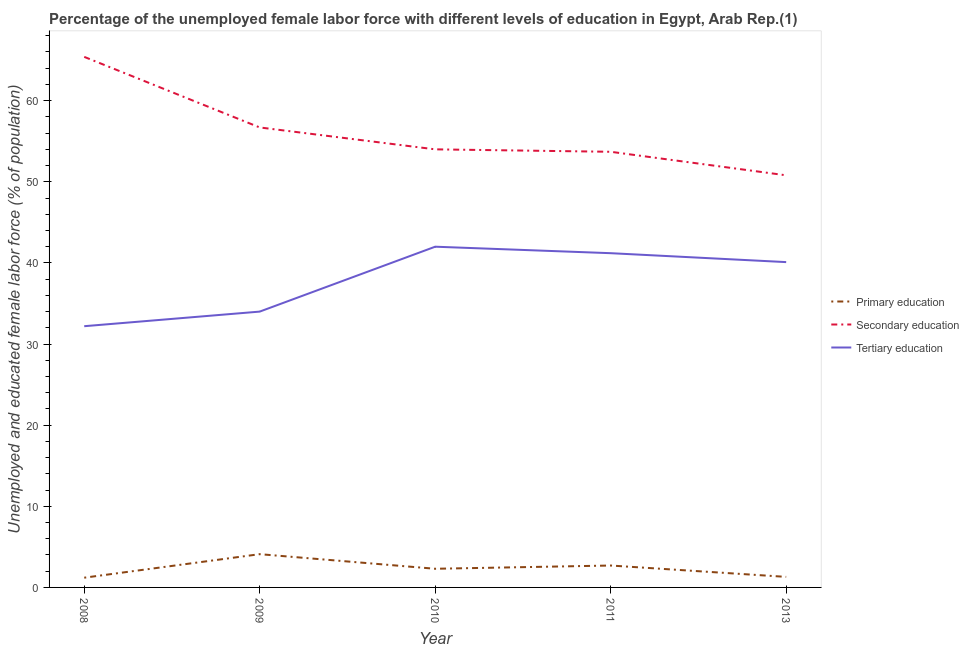How many different coloured lines are there?
Ensure brevity in your answer.  3. Does the line corresponding to percentage of female labor force who received primary education intersect with the line corresponding to percentage of female labor force who received secondary education?
Make the answer very short. No. What is the percentage of female labor force who received primary education in 2008?
Your answer should be compact. 1.2. Across all years, what is the minimum percentage of female labor force who received secondary education?
Ensure brevity in your answer.  50.8. In which year was the percentage of female labor force who received secondary education maximum?
Ensure brevity in your answer.  2008. In which year was the percentage of female labor force who received tertiary education minimum?
Provide a short and direct response. 2008. What is the total percentage of female labor force who received primary education in the graph?
Offer a very short reply. 11.6. What is the difference between the percentage of female labor force who received primary education in 2009 and that in 2013?
Keep it short and to the point. 2.8. What is the difference between the percentage of female labor force who received secondary education in 2010 and the percentage of female labor force who received tertiary education in 2011?
Provide a short and direct response. 12.8. What is the average percentage of female labor force who received secondary education per year?
Make the answer very short. 56.12. In the year 2009, what is the difference between the percentage of female labor force who received primary education and percentage of female labor force who received secondary education?
Keep it short and to the point. -52.6. What is the ratio of the percentage of female labor force who received tertiary education in 2008 to that in 2009?
Your response must be concise. 0.95. Is the difference between the percentage of female labor force who received primary education in 2008 and 2013 greater than the difference between the percentage of female labor force who received secondary education in 2008 and 2013?
Provide a succinct answer. No. What is the difference between the highest and the second highest percentage of female labor force who received primary education?
Ensure brevity in your answer.  1.4. What is the difference between the highest and the lowest percentage of female labor force who received secondary education?
Offer a terse response. 14.6. Is it the case that in every year, the sum of the percentage of female labor force who received primary education and percentage of female labor force who received secondary education is greater than the percentage of female labor force who received tertiary education?
Provide a succinct answer. Yes. Does the percentage of female labor force who received secondary education monotonically increase over the years?
Offer a very short reply. No. Is the percentage of female labor force who received tertiary education strictly less than the percentage of female labor force who received primary education over the years?
Give a very brief answer. No. How many years are there in the graph?
Provide a short and direct response. 5. What is the difference between two consecutive major ticks on the Y-axis?
Your answer should be very brief. 10. Are the values on the major ticks of Y-axis written in scientific E-notation?
Make the answer very short. No. What is the title of the graph?
Keep it short and to the point. Percentage of the unemployed female labor force with different levels of education in Egypt, Arab Rep.(1). Does "Unemployment benefits" appear as one of the legend labels in the graph?
Give a very brief answer. No. What is the label or title of the X-axis?
Keep it short and to the point. Year. What is the label or title of the Y-axis?
Your response must be concise. Unemployed and educated female labor force (% of population). What is the Unemployed and educated female labor force (% of population) in Primary education in 2008?
Your response must be concise. 1.2. What is the Unemployed and educated female labor force (% of population) in Secondary education in 2008?
Your answer should be compact. 65.4. What is the Unemployed and educated female labor force (% of population) in Tertiary education in 2008?
Make the answer very short. 32.2. What is the Unemployed and educated female labor force (% of population) in Primary education in 2009?
Keep it short and to the point. 4.1. What is the Unemployed and educated female labor force (% of population) of Secondary education in 2009?
Give a very brief answer. 56.7. What is the Unemployed and educated female labor force (% of population) in Primary education in 2010?
Your answer should be very brief. 2.3. What is the Unemployed and educated female labor force (% of population) of Secondary education in 2010?
Your answer should be compact. 54. What is the Unemployed and educated female labor force (% of population) in Tertiary education in 2010?
Your answer should be very brief. 42. What is the Unemployed and educated female labor force (% of population) of Primary education in 2011?
Make the answer very short. 2.7. What is the Unemployed and educated female labor force (% of population) in Secondary education in 2011?
Offer a very short reply. 53.7. What is the Unemployed and educated female labor force (% of population) in Tertiary education in 2011?
Offer a terse response. 41.2. What is the Unemployed and educated female labor force (% of population) of Primary education in 2013?
Provide a short and direct response. 1.3. What is the Unemployed and educated female labor force (% of population) in Secondary education in 2013?
Your response must be concise. 50.8. What is the Unemployed and educated female labor force (% of population) of Tertiary education in 2013?
Keep it short and to the point. 40.1. Across all years, what is the maximum Unemployed and educated female labor force (% of population) of Primary education?
Provide a short and direct response. 4.1. Across all years, what is the maximum Unemployed and educated female labor force (% of population) in Secondary education?
Your response must be concise. 65.4. Across all years, what is the maximum Unemployed and educated female labor force (% of population) in Tertiary education?
Ensure brevity in your answer.  42. Across all years, what is the minimum Unemployed and educated female labor force (% of population) of Primary education?
Your answer should be very brief. 1.2. Across all years, what is the minimum Unemployed and educated female labor force (% of population) in Secondary education?
Provide a short and direct response. 50.8. Across all years, what is the minimum Unemployed and educated female labor force (% of population) in Tertiary education?
Ensure brevity in your answer.  32.2. What is the total Unemployed and educated female labor force (% of population) of Secondary education in the graph?
Your response must be concise. 280.6. What is the total Unemployed and educated female labor force (% of population) of Tertiary education in the graph?
Keep it short and to the point. 189.5. What is the difference between the Unemployed and educated female labor force (% of population) of Tertiary education in 2008 and that in 2009?
Offer a very short reply. -1.8. What is the difference between the Unemployed and educated female labor force (% of population) of Tertiary education in 2008 and that in 2010?
Make the answer very short. -9.8. What is the difference between the Unemployed and educated female labor force (% of population) of Secondary education in 2008 and that in 2011?
Provide a succinct answer. 11.7. What is the difference between the Unemployed and educated female labor force (% of population) in Primary education in 2008 and that in 2013?
Give a very brief answer. -0.1. What is the difference between the Unemployed and educated female labor force (% of population) in Secondary education in 2008 and that in 2013?
Offer a very short reply. 14.6. What is the difference between the Unemployed and educated female labor force (% of population) in Tertiary education in 2008 and that in 2013?
Offer a very short reply. -7.9. What is the difference between the Unemployed and educated female labor force (% of population) of Primary education in 2009 and that in 2013?
Make the answer very short. 2.8. What is the difference between the Unemployed and educated female labor force (% of population) in Tertiary education in 2009 and that in 2013?
Offer a very short reply. -6.1. What is the difference between the Unemployed and educated female labor force (% of population) in Primary education in 2010 and that in 2011?
Keep it short and to the point. -0.4. What is the difference between the Unemployed and educated female labor force (% of population) in Secondary education in 2010 and that in 2011?
Provide a succinct answer. 0.3. What is the difference between the Unemployed and educated female labor force (% of population) of Primary education in 2010 and that in 2013?
Keep it short and to the point. 1. What is the difference between the Unemployed and educated female labor force (% of population) in Secondary education in 2010 and that in 2013?
Provide a succinct answer. 3.2. What is the difference between the Unemployed and educated female labor force (% of population) of Tertiary education in 2010 and that in 2013?
Your answer should be compact. 1.9. What is the difference between the Unemployed and educated female labor force (% of population) in Secondary education in 2011 and that in 2013?
Make the answer very short. 2.9. What is the difference between the Unemployed and educated female labor force (% of population) of Primary education in 2008 and the Unemployed and educated female labor force (% of population) of Secondary education in 2009?
Make the answer very short. -55.5. What is the difference between the Unemployed and educated female labor force (% of population) in Primary education in 2008 and the Unemployed and educated female labor force (% of population) in Tertiary education in 2009?
Give a very brief answer. -32.8. What is the difference between the Unemployed and educated female labor force (% of population) in Secondary education in 2008 and the Unemployed and educated female labor force (% of population) in Tertiary education in 2009?
Provide a succinct answer. 31.4. What is the difference between the Unemployed and educated female labor force (% of population) of Primary education in 2008 and the Unemployed and educated female labor force (% of population) of Secondary education in 2010?
Provide a short and direct response. -52.8. What is the difference between the Unemployed and educated female labor force (% of population) in Primary education in 2008 and the Unemployed and educated female labor force (% of population) in Tertiary education in 2010?
Your response must be concise. -40.8. What is the difference between the Unemployed and educated female labor force (% of population) in Secondary education in 2008 and the Unemployed and educated female labor force (% of population) in Tertiary education in 2010?
Ensure brevity in your answer.  23.4. What is the difference between the Unemployed and educated female labor force (% of population) of Primary education in 2008 and the Unemployed and educated female labor force (% of population) of Secondary education in 2011?
Provide a short and direct response. -52.5. What is the difference between the Unemployed and educated female labor force (% of population) in Primary education in 2008 and the Unemployed and educated female labor force (% of population) in Tertiary education in 2011?
Your answer should be very brief. -40. What is the difference between the Unemployed and educated female labor force (% of population) in Secondary education in 2008 and the Unemployed and educated female labor force (% of population) in Tertiary education in 2011?
Your answer should be compact. 24.2. What is the difference between the Unemployed and educated female labor force (% of population) of Primary education in 2008 and the Unemployed and educated female labor force (% of population) of Secondary education in 2013?
Ensure brevity in your answer.  -49.6. What is the difference between the Unemployed and educated female labor force (% of population) of Primary education in 2008 and the Unemployed and educated female labor force (% of population) of Tertiary education in 2013?
Make the answer very short. -38.9. What is the difference between the Unemployed and educated female labor force (% of population) of Secondary education in 2008 and the Unemployed and educated female labor force (% of population) of Tertiary education in 2013?
Your response must be concise. 25.3. What is the difference between the Unemployed and educated female labor force (% of population) of Primary education in 2009 and the Unemployed and educated female labor force (% of population) of Secondary education in 2010?
Your answer should be compact. -49.9. What is the difference between the Unemployed and educated female labor force (% of population) in Primary education in 2009 and the Unemployed and educated female labor force (% of population) in Tertiary education in 2010?
Provide a short and direct response. -37.9. What is the difference between the Unemployed and educated female labor force (% of population) of Secondary education in 2009 and the Unemployed and educated female labor force (% of population) of Tertiary education in 2010?
Provide a short and direct response. 14.7. What is the difference between the Unemployed and educated female labor force (% of population) of Primary education in 2009 and the Unemployed and educated female labor force (% of population) of Secondary education in 2011?
Keep it short and to the point. -49.6. What is the difference between the Unemployed and educated female labor force (% of population) of Primary education in 2009 and the Unemployed and educated female labor force (% of population) of Tertiary education in 2011?
Offer a terse response. -37.1. What is the difference between the Unemployed and educated female labor force (% of population) of Primary education in 2009 and the Unemployed and educated female labor force (% of population) of Secondary education in 2013?
Your answer should be compact. -46.7. What is the difference between the Unemployed and educated female labor force (% of population) of Primary education in 2009 and the Unemployed and educated female labor force (% of population) of Tertiary education in 2013?
Ensure brevity in your answer.  -36. What is the difference between the Unemployed and educated female labor force (% of population) in Secondary education in 2009 and the Unemployed and educated female labor force (% of population) in Tertiary education in 2013?
Offer a very short reply. 16.6. What is the difference between the Unemployed and educated female labor force (% of population) of Primary education in 2010 and the Unemployed and educated female labor force (% of population) of Secondary education in 2011?
Provide a succinct answer. -51.4. What is the difference between the Unemployed and educated female labor force (% of population) of Primary education in 2010 and the Unemployed and educated female labor force (% of population) of Tertiary education in 2011?
Give a very brief answer. -38.9. What is the difference between the Unemployed and educated female labor force (% of population) in Secondary education in 2010 and the Unemployed and educated female labor force (% of population) in Tertiary education in 2011?
Offer a very short reply. 12.8. What is the difference between the Unemployed and educated female labor force (% of population) of Primary education in 2010 and the Unemployed and educated female labor force (% of population) of Secondary education in 2013?
Provide a succinct answer. -48.5. What is the difference between the Unemployed and educated female labor force (% of population) of Primary education in 2010 and the Unemployed and educated female labor force (% of population) of Tertiary education in 2013?
Ensure brevity in your answer.  -37.8. What is the difference between the Unemployed and educated female labor force (% of population) in Primary education in 2011 and the Unemployed and educated female labor force (% of population) in Secondary education in 2013?
Your response must be concise. -48.1. What is the difference between the Unemployed and educated female labor force (% of population) in Primary education in 2011 and the Unemployed and educated female labor force (% of population) in Tertiary education in 2013?
Offer a terse response. -37.4. What is the average Unemployed and educated female labor force (% of population) of Primary education per year?
Give a very brief answer. 2.32. What is the average Unemployed and educated female labor force (% of population) of Secondary education per year?
Provide a succinct answer. 56.12. What is the average Unemployed and educated female labor force (% of population) of Tertiary education per year?
Make the answer very short. 37.9. In the year 2008, what is the difference between the Unemployed and educated female labor force (% of population) in Primary education and Unemployed and educated female labor force (% of population) in Secondary education?
Offer a very short reply. -64.2. In the year 2008, what is the difference between the Unemployed and educated female labor force (% of population) in Primary education and Unemployed and educated female labor force (% of population) in Tertiary education?
Offer a terse response. -31. In the year 2008, what is the difference between the Unemployed and educated female labor force (% of population) of Secondary education and Unemployed and educated female labor force (% of population) of Tertiary education?
Ensure brevity in your answer.  33.2. In the year 2009, what is the difference between the Unemployed and educated female labor force (% of population) in Primary education and Unemployed and educated female labor force (% of population) in Secondary education?
Provide a succinct answer. -52.6. In the year 2009, what is the difference between the Unemployed and educated female labor force (% of population) in Primary education and Unemployed and educated female labor force (% of population) in Tertiary education?
Your answer should be compact. -29.9. In the year 2009, what is the difference between the Unemployed and educated female labor force (% of population) in Secondary education and Unemployed and educated female labor force (% of population) in Tertiary education?
Your response must be concise. 22.7. In the year 2010, what is the difference between the Unemployed and educated female labor force (% of population) of Primary education and Unemployed and educated female labor force (% of population) of Secondary education?
Your response must be concise. -51.7. In the year 2010, what is the difference between the Unemployed and educated female labor force (% of population) in Primary education and Unemployed and educated female labor force (% of population) in Tertiary education?
Your answer should be compact. -39.7. In the year 2010, what is the difference between the Unemployed and educated female labor force (% of population) in Secondary education and Unemployed and educated female labor force (% of population) in Tertiary education?
Keep it short and to the point. 12. In the year 2011, what is the difference between the Unemployed and educated female labor force (% of population) in Primary education and Unemployed and educated female labor force (% of population) in Secondary education?
Provide a succinct answer. -51. In the year 2011, what is the difference between the Unemployed and educated female labor force (% of population) of Primary education and Unemployed and educated female labor force (% of population) of Tertiary education?
Ensure brevity in your answer.  -38.5. In the year 2013, what is the difference between the Unemployed and educated female labor force (% of population) in Primary education and Unemployed and educated female labor force (% of population) in Secondary education?
Give a very brief answer. -49.5. In the year 2013, what is the difference between the Unemployed and educated female labor force (% of population) in Primary education and Unemployed and educated female labor force (% of population) in Tertiary education?
Make the answer very short. -38.8. In the year 2013, what is the difference between the Unemployed and educated female labor force (% of population) of Secondary education and Unemployed and educated female labor force (% of population) of Tertiary education?
Your answer should be compact. 10.7. What is the ratio of the Unemployed and educated female labor force (% of population) of Primary education in 2008 to that in 2009?
Your answer should be very brief. 0.29. What is the ratio of the Unemployed and educated female labor force (% of population) in Secondary education in 2008 to that in 2009?
Your answer should be very brief. 1.15. What is the ratio of the Unemployed and educated female labor force (% of population) in Tertiary education in 2008 to that in 2009?
Provide a succinct answer. 0.95. What is the ratio of the Unemployed and educated female labor force (% of population) in Primary education in 2008 to that in 2010?
Your answer should be very brief. 0.52. What is the ratio of the Unemployed and educated female labor force (% of population) in Secondary education in 2008 to that in 2010?
Give a very brief answer. 1.21. What is the ratio of the Unemployed and educated female labor force (% of population) in Tertiary education in 2008 to that in 2010?
Provide a succinct answer. 0.77. What is the ratio of the Unemployed and educated female labor force (% of population) of Primary education in 2008 to that in 2011?
Ensure brevity in your answer.  0.44. What is the ratio of the Unemployed and educated female labor force (% of population) of Secondary education in 2008 to that in 2011?
Keep it short and to the point. 1.22. What is the ratio of the Unemployed and educated female labor force (% of population) of Tertiary education in 2008 to that in 2011?
Your response must be concise. 0.78. What is the ratio of the Unemployed and educated female labor force (% of population) in Primary education in 2008 to that in 2013?
Offer a very short reply. 0.92. What is the ratio of the Unemployed and educated female labor force (% of population) in Secondary education in 2008 to that in 2013?
Make the answer very short. 1.29. What is the ratio of the Unemployed and educated female labor force (% of population) of Tertiary education in 2008 to that in 2013?
Keep it short and to the point. 0.8. What is the ratio of the Unemployed and educated female labor force (% of population) in Primary education in 2009 to that in 2010?
Your response must be concise. 1.78. What is the ratio of the Unemployed and educated female labor force (% of population) of Tertiary education in 2009 to that in 2010?
Offer a very short reply. 0.81. What is the ratio of the Unemployed and educated female labor force (% of population) of Primary education in 2009 to that in 2011?
Offer a very short reply. 1.52. What is the ratio of the Unemployed and educated female labor force (% of population) in Secondary education in 2009 to that in 2011?
Provide a short and direct response. 1.06. What is the ratio of the Unemployed and educated female labor force (% of population) of Tertiary education in 2009 to that in 2011?
Offer a terse response. 0.83. What is the ratio of the Unemployed and educated female labor force (% of population) in Primary education in 2009 to that in 2013?
Keep it short and to the point. 3.15. What is the ratio of the Unemployed and educated female labor force (% of population) in Secondary education in 2009 to that in 2013?
Your answer should be compact. 1.12. What is the ratio of the Unemployed and educated female labor force (% of population) of Tertiary education in 2009 to that in 2013?
Your response must be concise. 0.85. What is the ratio of the Unemployed and educated female labor force (% of population) of Primary education in 2010 to that in 2011?
Provide a succinct answer. 0.85. What is the ratio of the Unemployed and educated female labor force (% of population) of Secondary education in 2010 to that in 2011?
Ensure brevity in your answer.  1.01. What is the ratio of the Unemployed and educated female labor force (% of population) of Tertiary education in 2010 to that in 2011?
Your answer should be very brief. 1.02. What is the ratio of the Unemployed and educated female labor force (% of population) of Primary education in 2010 to that in 2013?
Offer a terse response. 1.77. What is the ratio of the Unemployed and educated female labor force (% of population) in Secondary education in 2010 to that in 2013?
Your answer should be very brief. 1.06. What is the ratio of the Unemployed and educated female labor force (% of population) of Tertiary education in 2010 to that in 2013?
Make the answer very short. 1.05. What is the ratio of the Unemployed and educated female labor force (% of population) of Primary education in 2011 to that in 2013?
Offer a very short reply. 2.08. What is the ratio of the Unemployed and educated female labor force (% of population) of Secondary education in 2011 to that in 2013?
Offer a terse response. 1.06. What is the ratio of the Unemployed and educated female labor force (% of population) in Tertiary education in 2011 to that in 2013?
Your response must be concise. 1.03. What is the difference between the highest and the second highest Unemployed and educated female labor force (% of population) in Secondary education?
Your answer should be compact. 8.7. What is the difference between the highest and the second highest Unemployed and educated female labor force (% of population) in Tertiary education?
Ensure brevity in your answer.  0.8. What is the difference between the highest and the lowest Unemployed and educated female labor force (% of population) of Tertiary education?
Your answer should be compact. 9.8. 